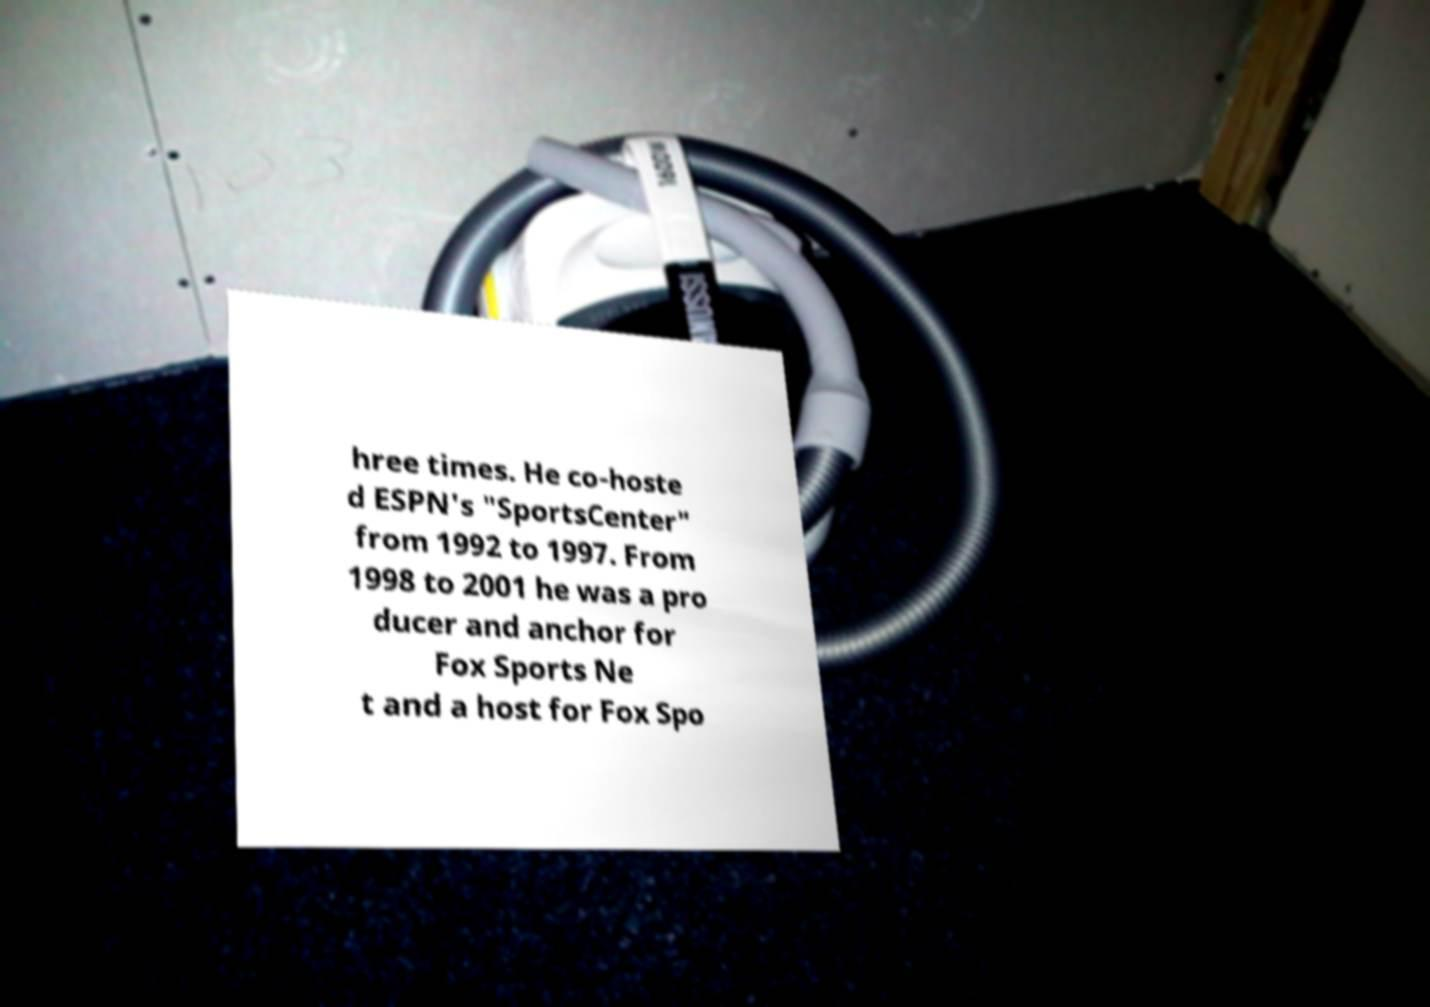Please identify and transcribe the text found in this image. hree times. He co-hoste d ESPN's "SportsCenter" from 1992 to 1997. From 1998 to 2001 he was a pro ducer and anchor for Fox Sports Ne t and a host for Fox Spo 